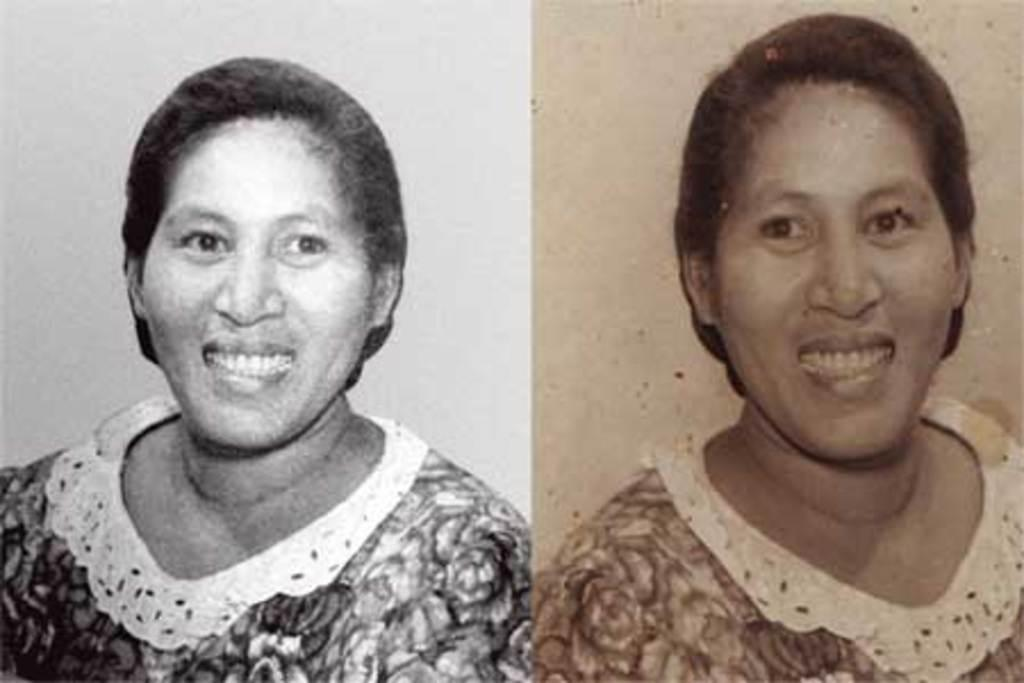What is the main subject of the picture? The main subject of the picture is a collage image of a woman. How many different images of the woman are included in the collage? There are two different images of the woman in the collage. Can you describe the appearance of the two images? One image of the woman is black and white, while the other image is shaded. What type of pest can be seen crawling on the woman's face in the image? There are no pests visible on the woman's face in the image. How many ducks are present in the image? There are no ducks present in the image; it features a collage of a woman. 